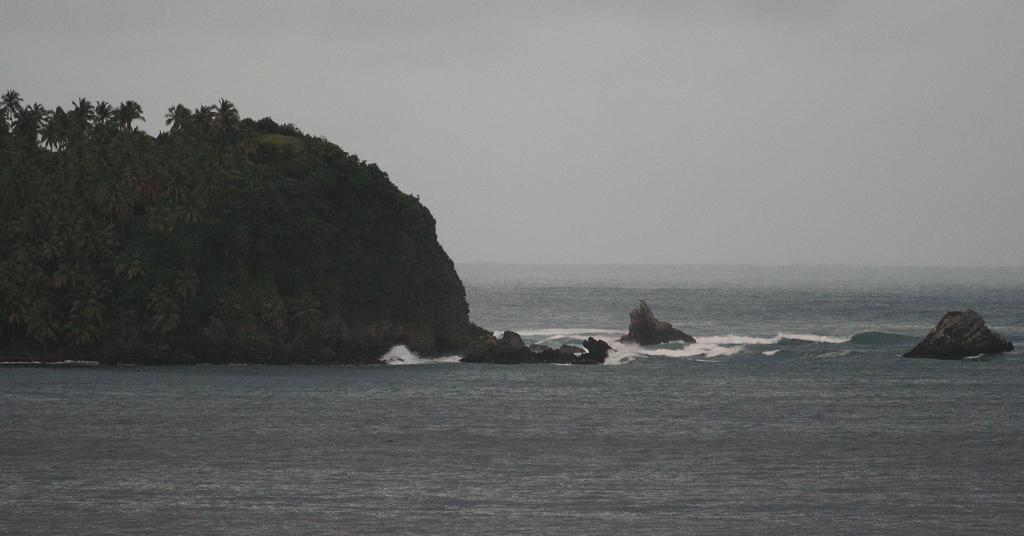Could you give a brief overview of what you see in this image? On the left side, there are trees and plants on the mountain which is in the water. On the right side, there are rocks. In the background, there is sky. 